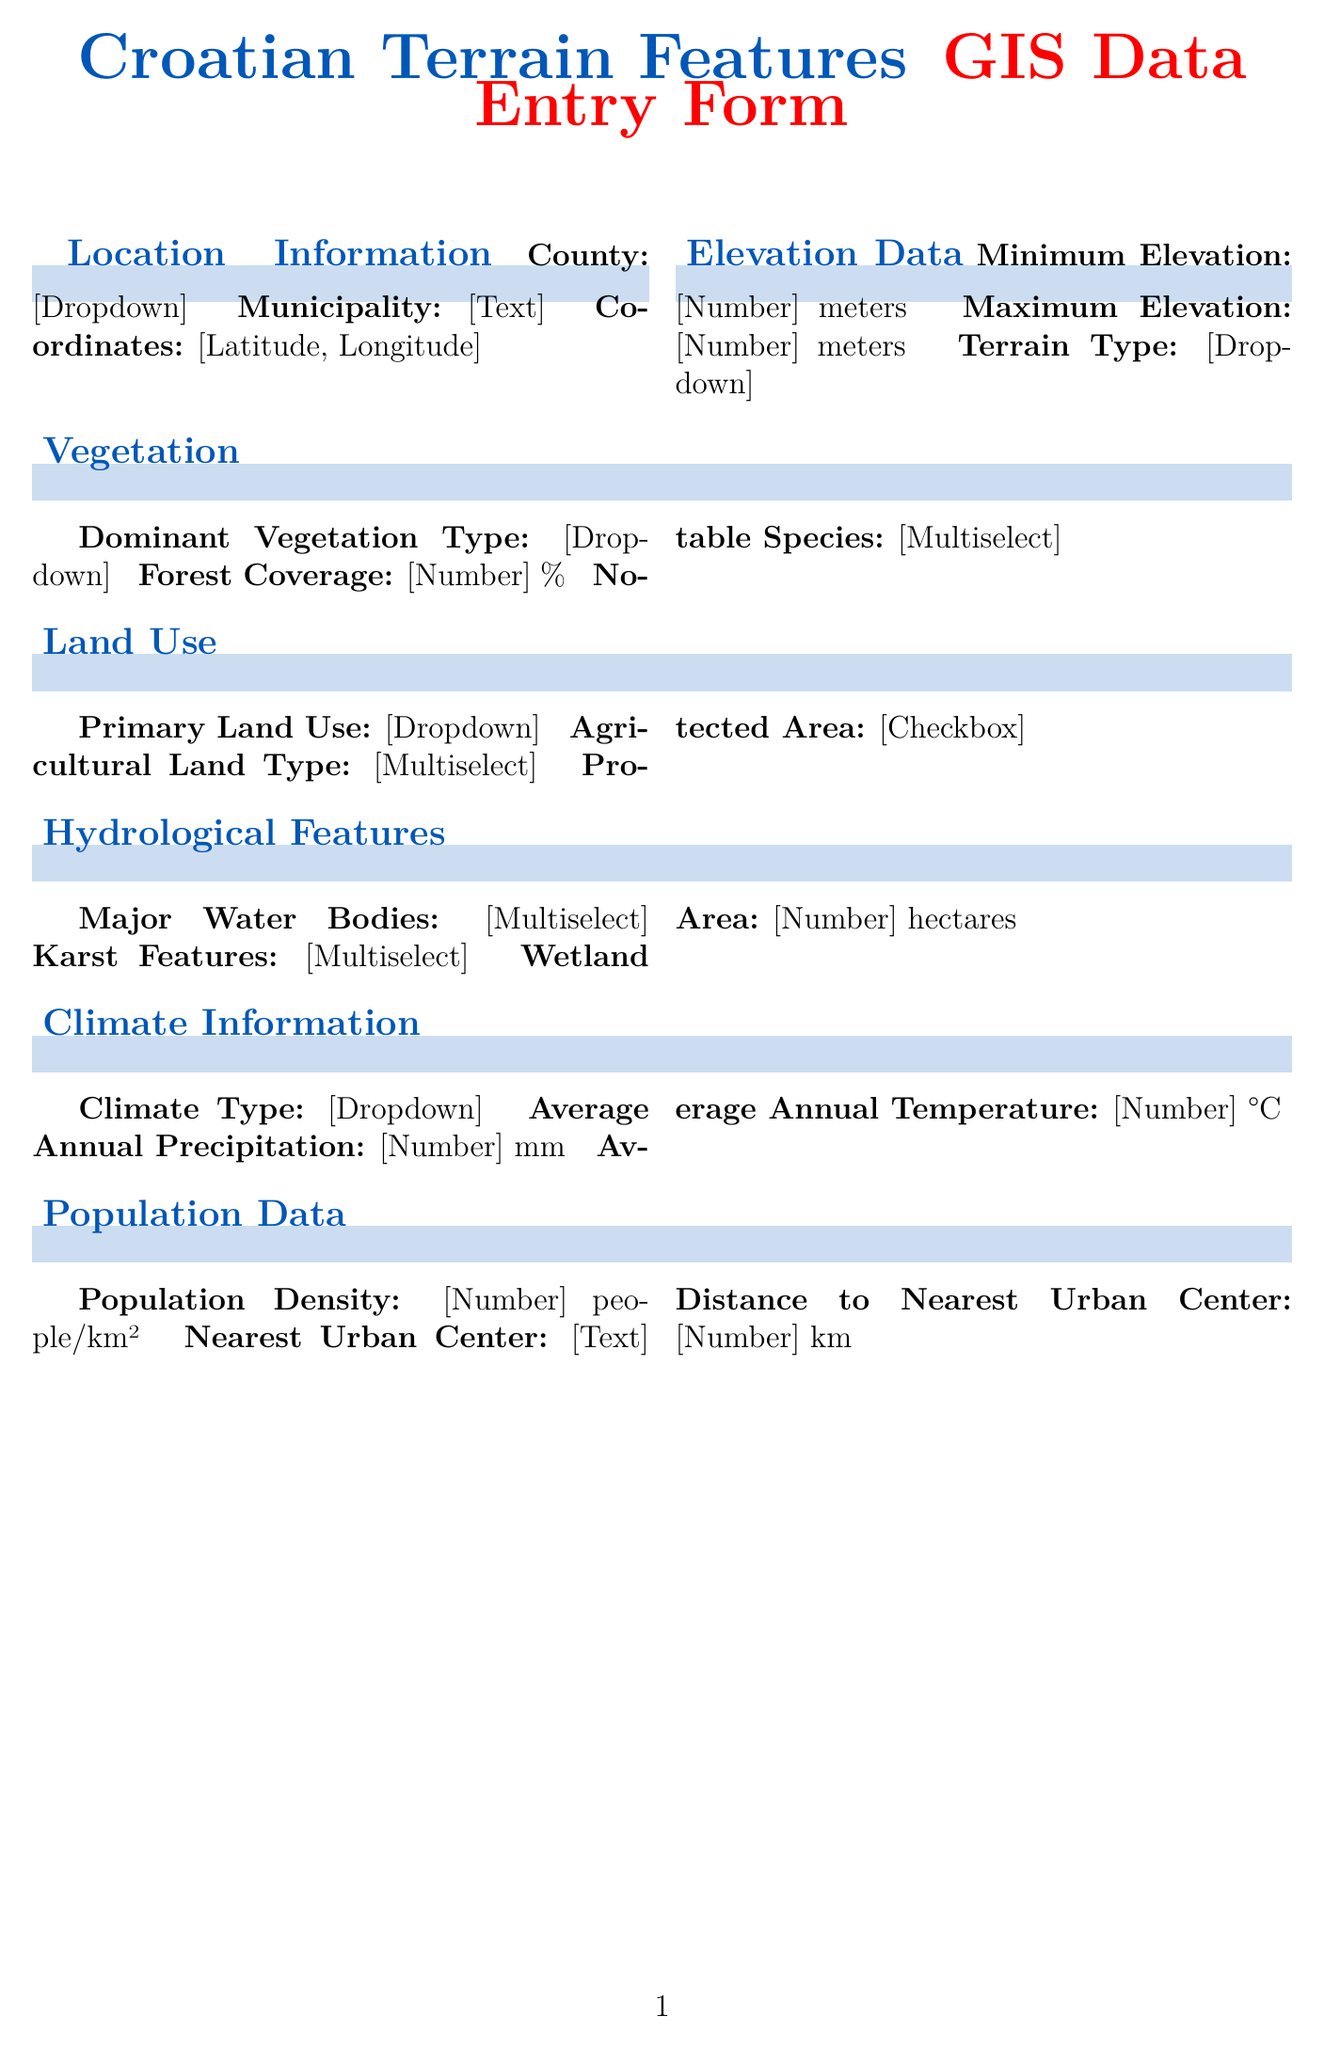What is the title of the form? The title of the form is indicated at the top of the document as "Croatian Terrain Features GIS Data Entry Form."
Answer: Croatian Terrain Features GIS Data Entry Form How many counties are listed in the County dropdown? The County dropdown includes options that can be counted; there are 21 options in total.
Answer: 21 What unit is used for Minimum Elevation? The Minimum Elevation field specifies a unit that is in meters.
Answer: meters Which section includes Major Water Bodies? The Major Water Bodies field is found within the Hydrological Features section of the form.
Answer: Hydrological Features What is the average annual precipitation unit? The Average Annual Precipitation field specifies a unit that is in millimeters.
Answer: mm What are the notable species options in the Vegetation section? The notable species can be found in a multiselect field under the Vegetation section, which lists multiple species names.
Answer: Quercus robur, Fagus sylvatica, Abies alba, Pinus nigra, Carpinus betulus, Fraxinus angustifolia, Quercus ilex, Pinus halepensis Which type of climate is included in the Climate Type dropdown? The Climate Type dropdown includes options that describe different climatic regions; one of these regions is specified as Mediterranean.
Answer: Mediterranean What is the unit for Population Density? The Population Density field specifies a unit that is in people per square kilometer.
Answer: people/km² 